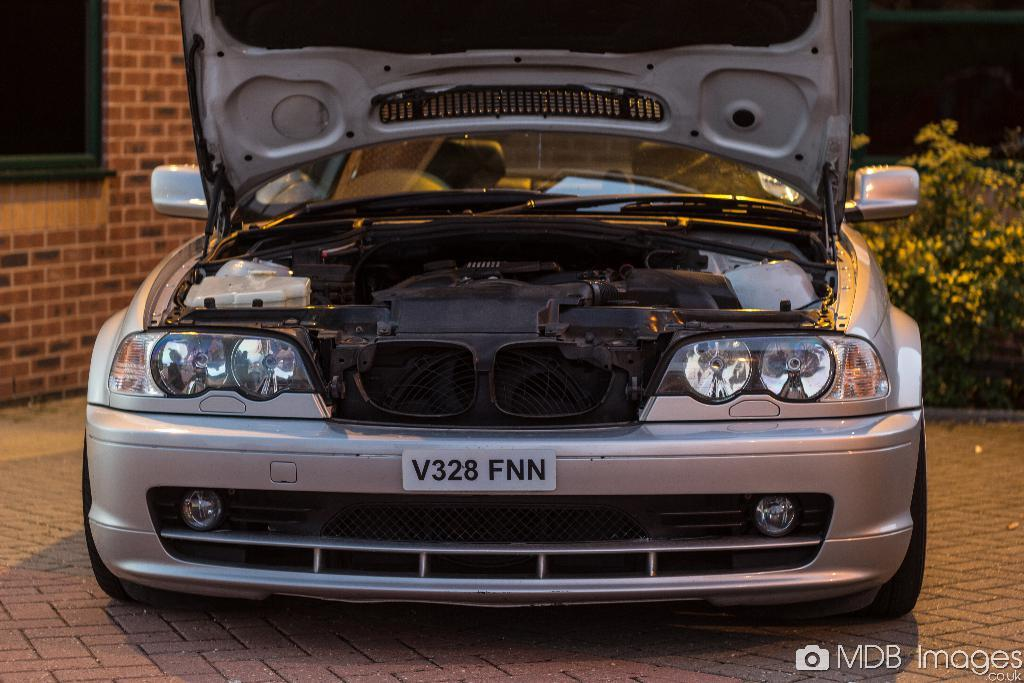What object is placed on the floor in the image? There is a car on the floor in the image. What type of vegetation is on the right side of the image? There are plants on the right side of the image. What can be seen in the background of the image? There is a wall with a window in the background of the image. What type of poison is being used to water the plants in the image? There is no indication of any poison being used to water the plants in the image. The plants appear to be healthy and well-maintained. 